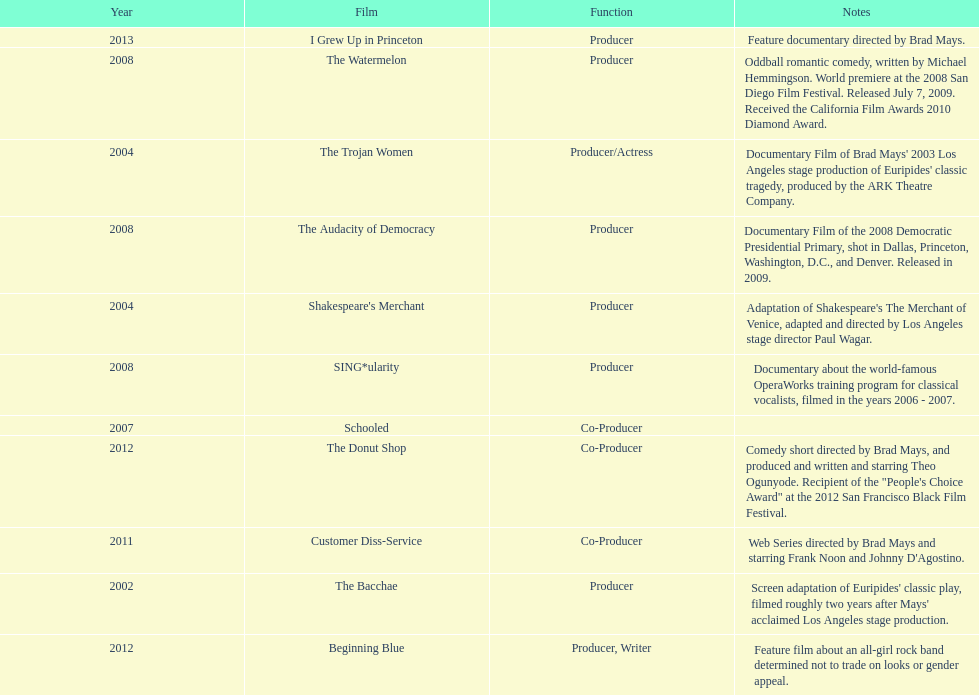Which film was before the audacity of democracy? The Watermelon. 